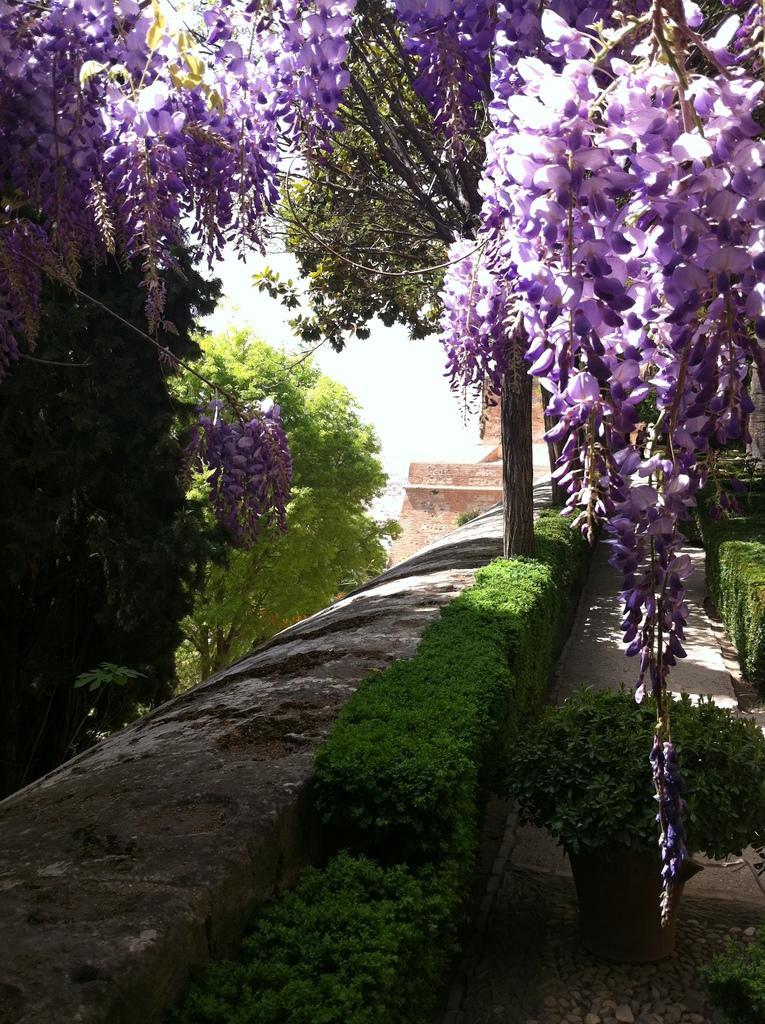How would you summarize this image in a sentence or two? In this image I can see the plants. At the top I can see the flowers. 